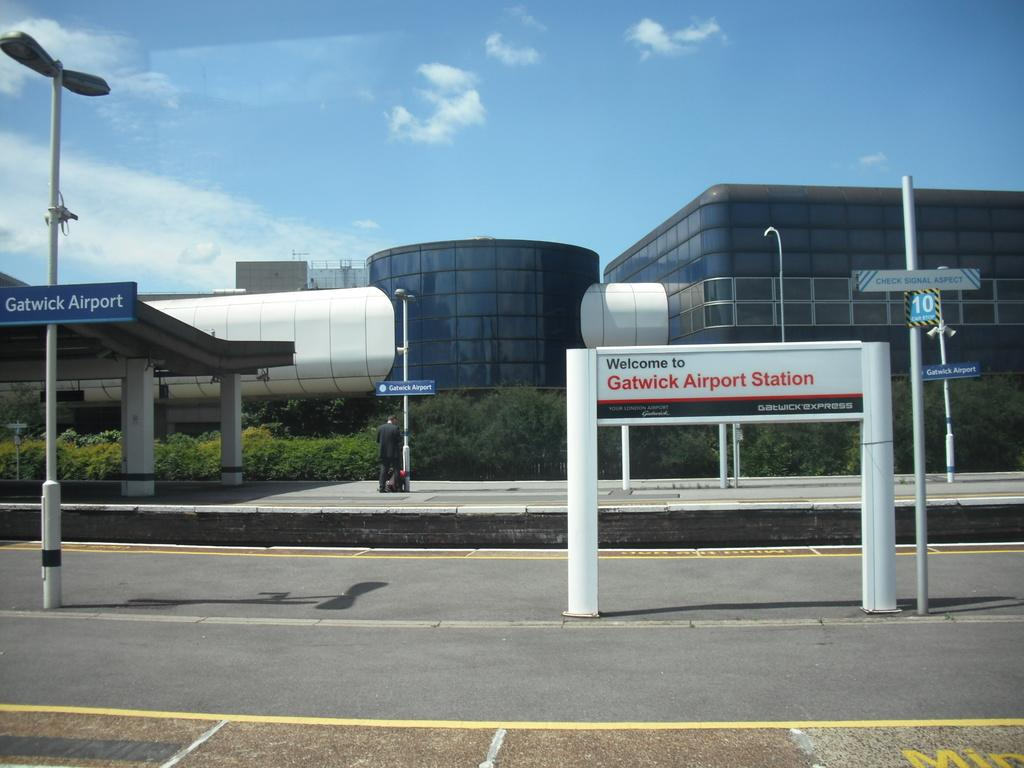What type of building can be seen in the image? There is a glass building in the image. What structures are present in the image besides the building? There are poles, boards with text, lights, a path, a shed, and pillars in the image. What type of vegetation is present in the image? There are plants in the image. What is visible in the sky in the image? The sky is visible in the image, and there are clouds in the sky. What type of toothbrush can be seen in the image? There is no toothbrush present in the image. 